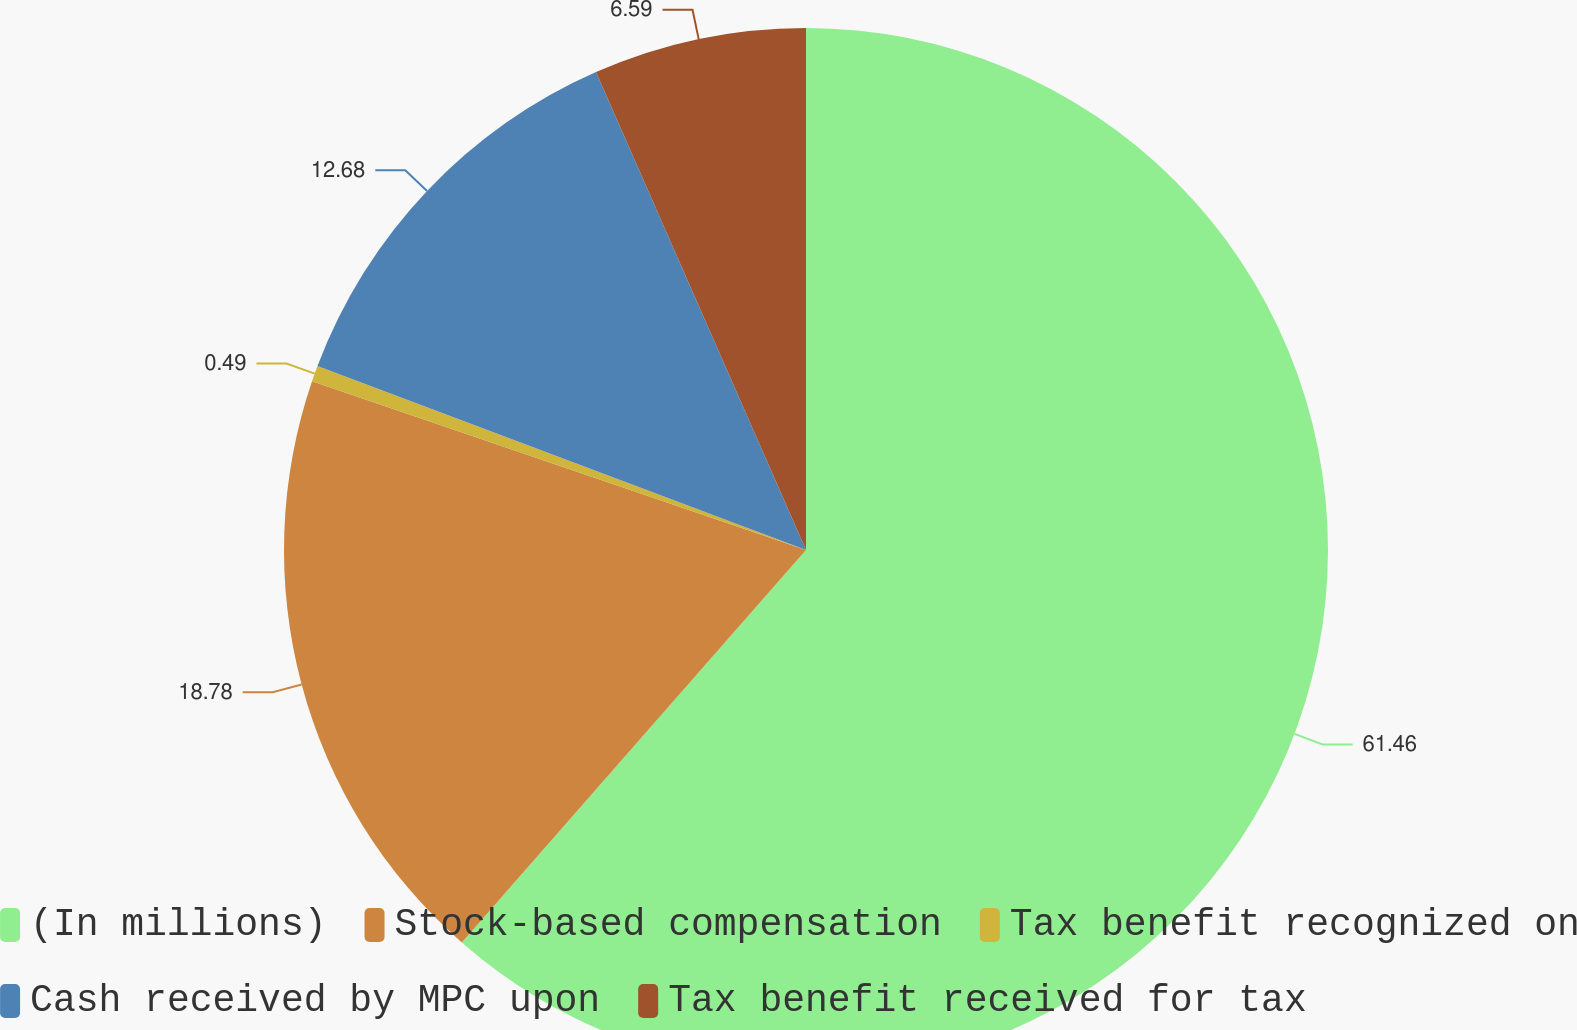<chart> <loc_0><loc_0><loc_500><loc_500><pie_chart><fcel>(In millions)<fcel>Stock-based compensation<fcel>Tax benefit recognized on<fcel>Cash received by MPC upon<fcel>Tax benefit received for tax<nl><fcel>61.46%<fcel>18.78%<fcel>0.49%<fcel>12.68%<fcel>6.59%<nl></chart> 